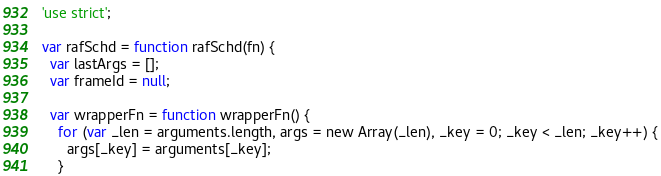Convert code to text. <code><loc_0><loc_0><loc_500><loc_500><_JavaScript_>'use strict';

var rafSchd = function rafSchd(fn) {
  var lastArgs = [];
  var frameId = null;

  var wrapperFn = function wrapperFn() {
    for (var _len = arguments.length, args = new Array(_len), _key = 0; _key < _len; _key++) {
      args[_key] = arguments[_key];
    }
</code> 